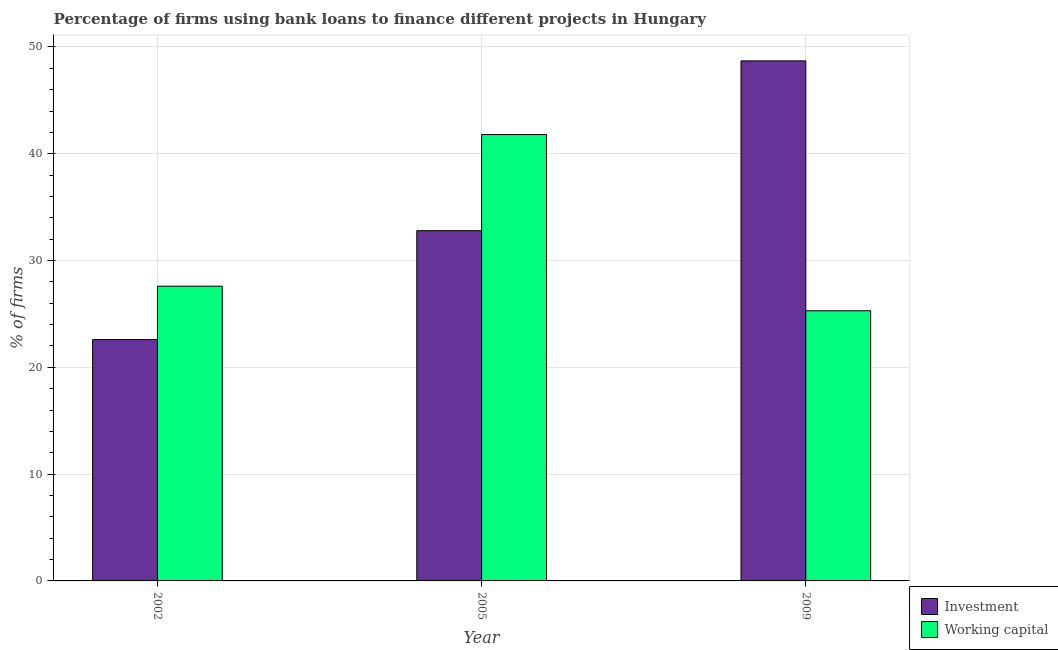How many groups of bars are there?
Your response must be concise. 3. How many bars are there on the 1st tick from the right?
Your response must be concise. 2. What is the label of the 3rd group of bars from the left?
Your answer should be compact. 2009. What is the percentage of firms using banks to finance investment in 2002?
Ensure brevity in your answer.  22.6. Across all years, what is the maximum percentage of firms using banks to finance investment?
Offer a very short reply. 48.7. Across all years, what is the minimum percentage of firms using banks to finance investment?
Make the answer very short. 22.6. In which year was the percentage of firms using banks to finance working capital maximum?
Your response must be concise. 2005. In which year was the percentage of firms using banks to finance investment minimum?
Give a very brief answer. 2002. What is the total percentage of firms using banks to finance working capital in the graph?
Offer a very short reply. 94.7. What is the difference between the percentage of firms using banks to finance working capital in 2002 and that in 2009?
Give a very brief answer. 2.3. What is the difference between the percentage of firms using banks to finance working capital in 2005 and the percentage of firms using banks to finance investment in 2002?
Give a very brief answer. 14.2. What is the average percentage of firms using banks to finance working capital per year?
Give a very brief answer. 31.57. In the year 2005, what is the difference between the percentage of firms using banks to finance investment and percentage of firms using banks to finance working capital?
Your response must be concise. 0. What is the ratio of the percentage of firms using banks to finance investment in 2002 to that in 2005?
Your response must be concise. 0.69. Is the difference between the percentage of firms using banks to finance working capital in 2002 and 2009 greater than the difference between the percentage of firms using banks to finance investment in 2002 and 2009?
Make the answer very short. No. What is the difference between the highest and the second highest percentage of firms using banks to finance working capital?
Give a very brief answer. 14.2. What is the difference between the highest and the lowest percentage of firms using banks to finance working capital?
Your answer should be very brief. 16.5. What does the 2nd bar from the left in 2009 represents?
Give a very brief answer. Working capital. What does the 2nd bar from the right in 2009 represents?
Your response must be concise. Investment. How many bars are there?
Provide a short and direct response. 6. Does the graph contain any zero values?
Make the answer very short. No. How are the legend labels stacked?
Ensure brevity in your answer.  Vertical. What is the title of the graph?
Offer a terse response. Percentage of firms using bank loans to finance different projects in Hungary. What is the label or title of the X-axis?
Your answer should be compact. Year. What is the label or title of the Y-axis?
Your response must be concise. % of firms. What is the % of firms of Investment in 2002?
Give a very brief answer. 22.6. What is the % of firms of Working capital in 2002?
Your response must be concise. 27.6. What is the % of firms of Investment in 2005?
Provide a short and direct response. 32.8. What is the % of firms of Working capital in 2005?
Keep it short and to the point. 41.8. What is the % of firms of Investment in 2009?
Provide a short and direct response. 48.7. What is the % of firms of Working capital in 2009?
Provide a short and direct response. 25.3. Across all years, what is the maximum % of firms of Investment?
Provide a short and direct response. 48.7. Across all years, what is the maximum % of firms of Working capital?
Give a very brief answer. 41.8. Across all years, what is the minimum % of firms in Investment?
Your response must be concise. 22.6. Across all years, what is the minimum % of firms in Working capital?
Make the answer very short. 25.3. What is the total % of firms of Investment in the graph?
Your response must be concise. 104.1. What is the total % of firms in Working capital in the graph?
Provide a short and direct response. 94.7. What is the difference between the % of firms in Investment in 2002 and that in 2005?
Give a very brief answer. -10.2. What is the difference between the % of firms in Working capital in 2002 and that in 2005?
Your response must be concise. -14.2. What is the difference between the % of firms in Investment in 2002 and that in 2009?
Provide a succinct answer. -26.1. What is the difference between the % of firms in Working capital in 2002 and that in 2009?
Ensure brevity in your answer.  2.3. What is the difference between the % of firms in Investment in 2005 and that in 2009?
Keep it short and to the point. -15.9. What is the difference between the % of firms in Investment in 2002 and the % of firms in Working capital in 2005?
Offer a very short reply. -19.2. What is the average % of firms in Investment per year?
Your answer should be compact. 34.7. What is the average % of firms of Working capital per year?
Your answer should be compact. 31.57. In the year 2009, what is the difference between the % of firms in Investment and % of firms in Working capital?
Provide a short and direct response. 23.4. What is the ratio of the % of firms of Investment in 2002 to that in 2005?
Ensure brevity in your answer.  0.69. What is the ratio of the % of firms in Working capital in 2002 to that in 2005?
Your answer should be very brief. 0.66. What is the ratio of the % of firms in Investment in 2002 to that in 2009?
Provide a short and direct response. 0.46. What is the ratio of the % of firms of Working capital in 2002 to that in 2009?
Give a very brief answer. 1.09. What is the ratio of the % of firms of Investment in 2005 to that in 2009?
Make the answer very short. 0.67. What is the ratio of the % of firms of Working capital in 2005 to that in 2009?
Make the answer very short. 1.65. What is the difference between the highest and the second highest % of firms of Investment?
Provide a succinct answer. 15.9. What is the difference between the highest and the second highest % of firms of Working capital?
Provide a short and direct response. 14.2. What is the difference between the highest and the lowest % of firms in Investment?
Your answer should be compact. 26.1. What is the difference between the highest and the lowest % of firms in Working capital?
Give a very brief answer. 16.5. 